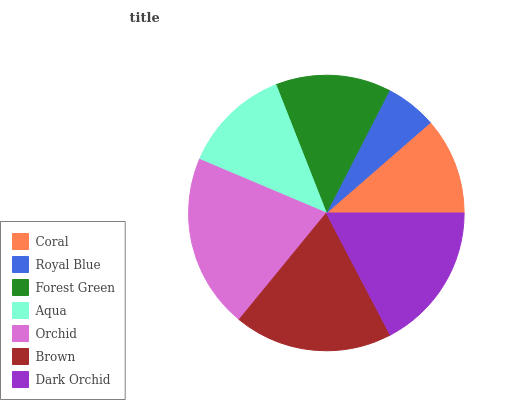Is Royal Blue the minimum?
Answer yes or no. Yes. Is Orchid the maximum?
Answer yes or no. Yes. Is Forest Green the minimum?
Answer yes or no. No. Is Forest Green the maximum?
Answer yes or no. No. Is Forest Green greater than Royal Blue?
Answer yes or no. Yes. Is Royal Blue less than Forest Green?
Answer yes or no. Yes. Is Royal Blue greater than Forest Green?
Answer yes or no. No. Is Forest Green less than Royal Blue?
Answer yes or no. No. Is Forest Green the high median?
Answer yes or no. Yes. Is Forest Green the low median?
Answer yes or no. Yes. Is Coral the high median?
Answer yes or no. No. Is Dark Orchid the low median?
Answer yes or no. No. 